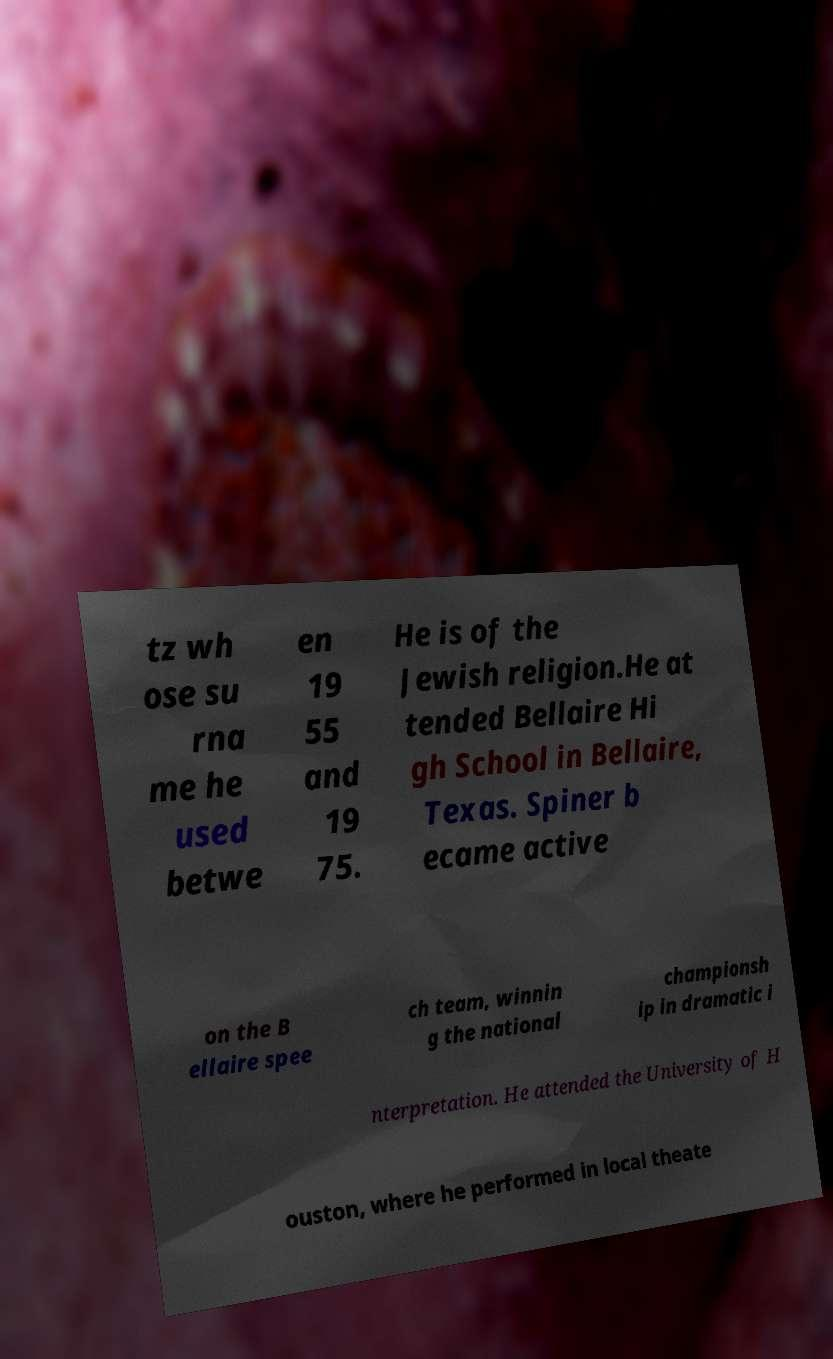Can you accurately transcribe the text from the provided image for me? tz wh ose su rna me he used betwe en 19 55 and 19 75. He is of the Jewish religion.He at tended Bellaire Hi gh School in Bellaire, Texas. Spiner b ecame active on the B ellaire spee ch team, winnin g the national championsh ip in dramatic i nterpretation. He attended the University of H ouston, where he performed in local theate 